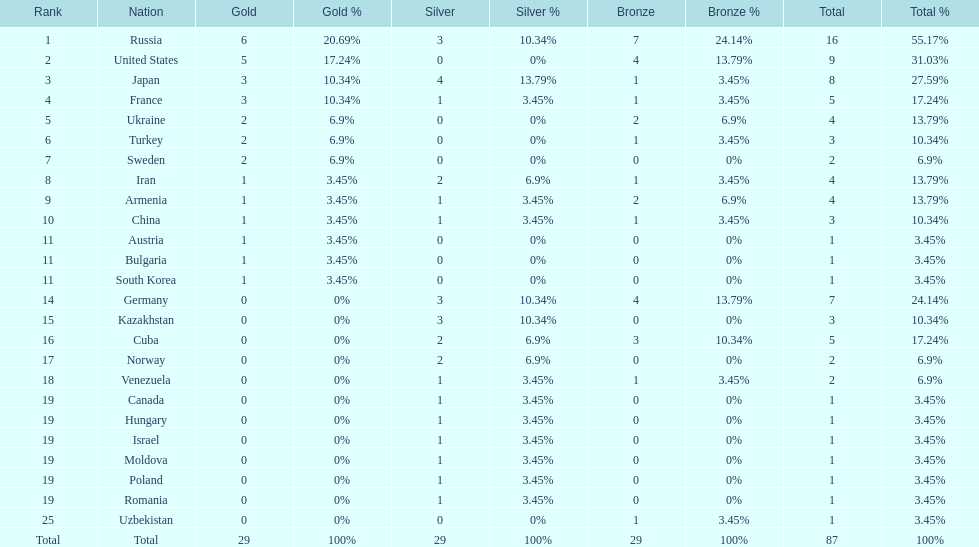Who ranked right after turkey? Sweden. 